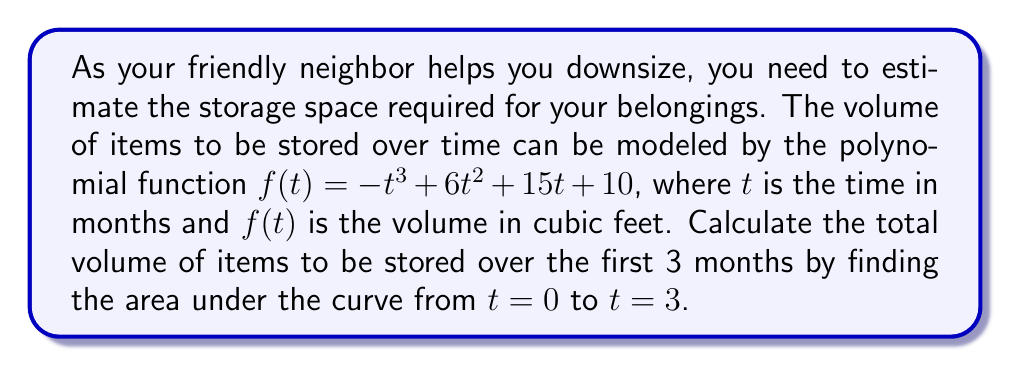Give your solution to this math problem. To find the area under the curve, we need to integrate the function $f(t)$ from $t=0$ to $t=3$.

Step 1: Set up the definite integral
$$\int_0^3 (-t^3 + 6t^2 + 15t + 10) dt$$

Step 2: Integrate the polynomial term by term
$$\left[-\frac{t^4}{4} + 2t^3 + \frac{15t^2}{2} + 10t\right]_0^3$$

Step 3: Evaluate the integral at the upper and lower bounds
Upper bound (t = 3):
$$-\frac{3^4}{4} + 2(3^3) + \frac{15(3^2)}{2} + 10(3) = -20.25 + 54 + 67.5 + 30 = 131.25$$

Lower bound (t = 0):
$$-\frac{0^4}{4} + 2(0^3) + \frac{15(0^2)}{2} + 10(0) = 0$$

Step 4: Subtract the lower bound from the upper bound
$$131.25 - 0 = 131.25$$

Therefore, the total volume of items to be stored over the first 3 months is 131.25 cubic feet.
Answer: 131.25 cubic feet 